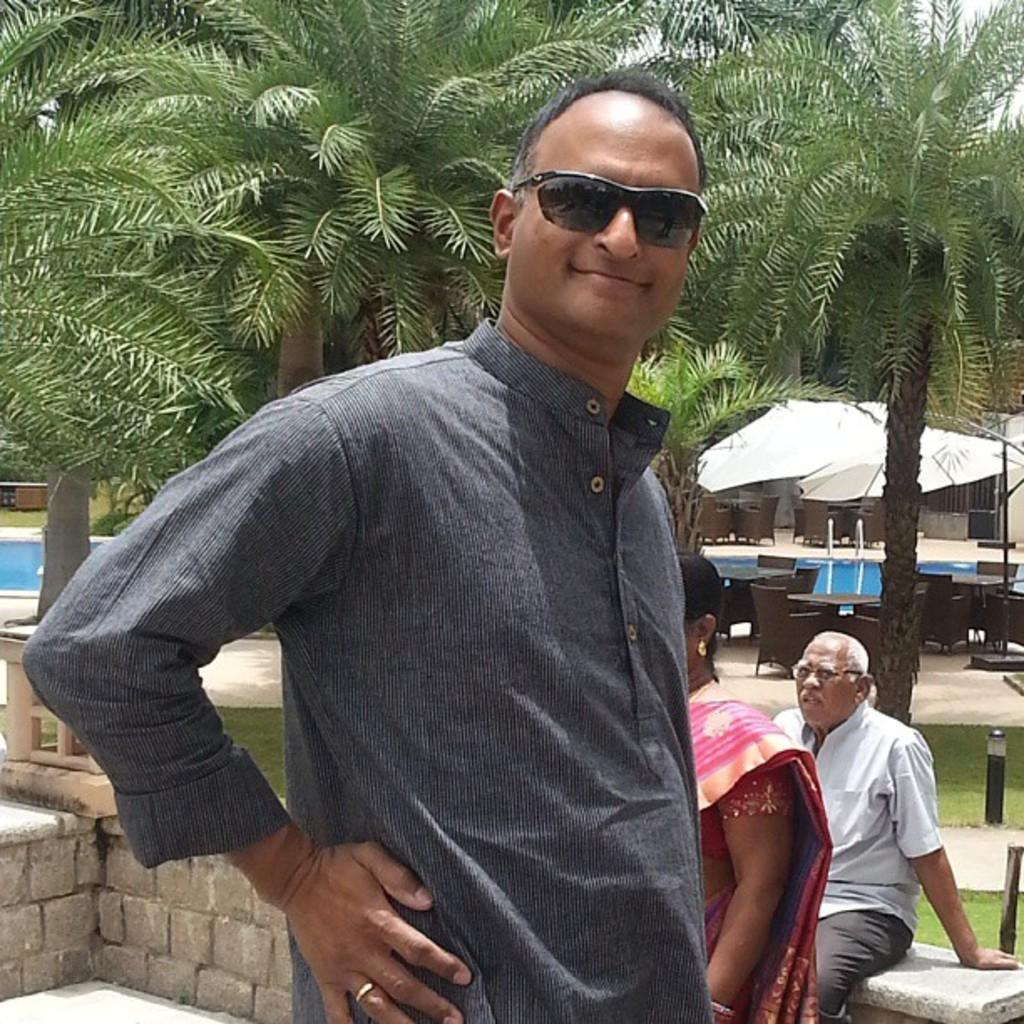How many people are present in the image? There are three people in the image. What can be observed about the clothing of the people in the image? The people are wearing different color dresses. What can be seen in the background of the image? There are trees, tents, water, and the sky visible in the background of the image. What type of cushion is being used by the sister in the image? There is no sister or cushion present in the image. How many cars can be seen in the image? There are no cars visible in the image. 